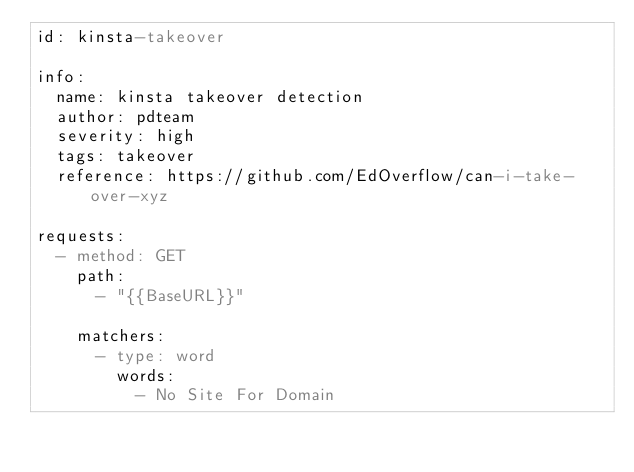<code> <loc_0><loc_0><loc_500><loc_500><_YAML_>id: kinsta-takeover

info:
  name: kinsta takeover detection
  author: pdteam
  severity: high
  tags: takeover
  reference: https://github.com/EdOverflow/can-i-take-over-xyz

requests:
  - method: GET
    path:
      - "{{BaseURL}}"

    matchers:
      - type: word
        words:
          - No Site For Domain</code> 